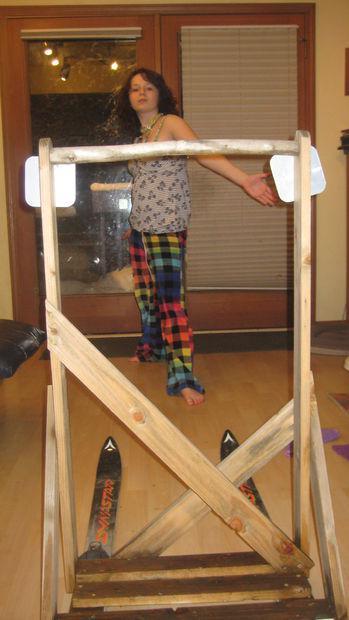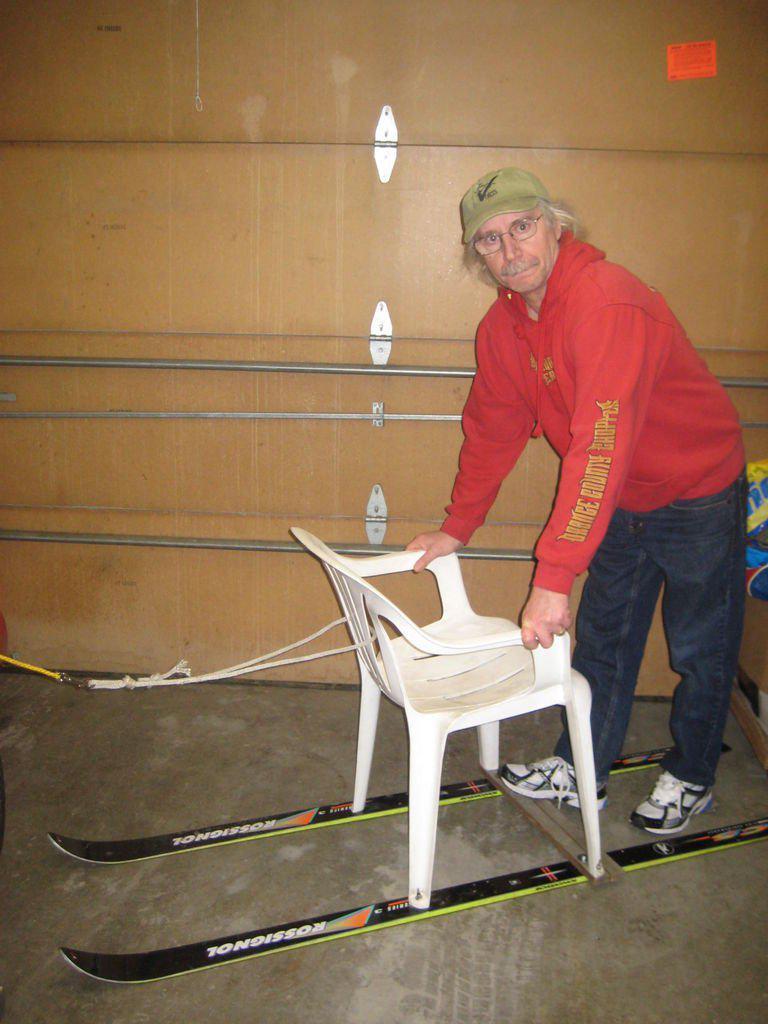The first image is the image on the left, the second image is the image on the right. Examine the images to the left and right. Is the description "There is at least one person pictured with a sled like object." accurate? Answer yes or no. Yes. The first image is the image on the left, the second image is the image on the right. Analyze the images presented: Is the assertion "There are two pairs of downhill skis." valid? Answer yes or no. Yes. 